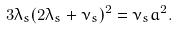<formula> <loc_0><loc_0><loc_500><loc_500>3 \lambda _ { s } ( 2 \lambda _ { s } + \nu _ { s } ) ^ { 2 } = \nu _ { s } a ^ { 2 } .</formula> 